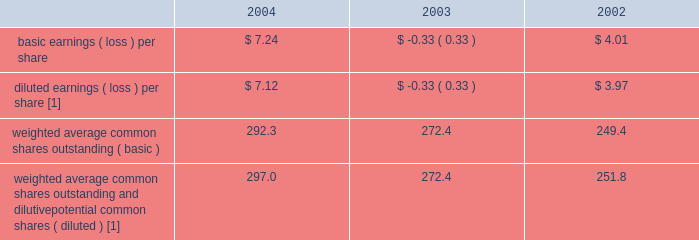Income was due primarily to the adoption of statement of position 03-1 , 201caccounting and reporting by insurance enterprises for certain nontraditional long-duration contracts and for separate accounts 201d ( 201csop 03-1 201d ) , which resulted in $ 1.6 billion of net investment income .
2003 compared to 2002 2014 revenues for the year ended december 31 , 2003 increased $ 2.3 billion over the comparable 2002 period .
Revenues increased due to earned premium growth within the business insurance , specialty commercial and personal lines segments , primarily as a result of earned pricing increases , higher earned premiums and net investment income in the retail products segment and net realized capital gains in 2003 as compared to net realized capital losses in 2002 .
Total benefits , claims and expenses increased $ 3.9 billion for the year ended december 31 , 2003 over the comparable prior year period primarily due to the company 2019s $ 2.6 billion asbestos reserve strengthening during the first quarter of 2003 and due to increases in the retail products segment associated with the growth in the individual annuity and institutional investments businesses .
The net loss for the year ended december 31 , 2003 was primarily due to the company 2019s first quarter 2003 asbestos reserve strengthening of $ 1.7 billion , after-tax .
Included in net loss for the year ended december 31 , 2003 are $ 40 of after-tax expense related to the settlement of litigation with bancorp services , llc ( 201cbancorp 201d ) and $ 27 of severance charges , after-tax , in property & casualty .
Included in net income for the year ended december 31 , 2002 are the $ 8 after-tax benefit recognized by hartford life , inc .
( 201chli 201d ) related to the reduction of hli 2019s reserves associated with september 11 and $ 11 of after-tax expense related to litigation with bancorp .
Net realized capital gains and losses see 201cinvestment results 201d in the investments section .
Income taxes the effective tax rate for 2004 , 2003 and 2002 was 15% ( 15 % ) , 83% ( 83 % ) and 6% ( 6 % ) , respectively .
The principal causes of the difference between the effective rates and the u.s .
Statutory rate of 35% ( 35 % ) were tax-exempt interest earned on invested assets , the dividends-received deduction , the tax benefit associated with the settlement of the 1998-2001 irs audit in 2004 and the tax benefit associated with the settlement of the 1996-1997 irs audit in 2002 .
Income taxes paid ( received ) in 2004 , 2003 and 2002 were $ 32 , ( $ 107 ) and ( $ 102 ) respectively .
For additional information , see note 13 of notes to consolidated financial statements .
Per common share the table represents earnings per common share data for the past three years: .
[1] as a result of the net loss for the year ended december 31 , 2003 , sfas no .
128 , 201cearnings per share 201d , requires the company to use basic weighted average common shares outstanding in the calculation of the year ended december 31 , 2003 diluted earnings ( loss ) per share , since the inclusion of options of 1.8 would have been antidilutive to the earnings per share calculation .
In the absence of the net loss , weighted average common shares outstanding and dilutive potential common shares would have totaled 274.2 .
Executive overview the company provides investment and retirement products such as variable and fixed annuities , mutual funds and retirement plan services and other institutional products ; individual and corporate owned life insurance ; and , group benefit products , such as group life and group disability insurance .
The company derives its revenues principally from : ( a ) fee income , including asset management fees , on separate account and mutual fund assets and mortality and expense fees , as well as cost of insurance charges ; ( b ) net investment income on general account assets ; ( c ) fully insured premiums ; and ( d ) certain other fees .
Asset management fees and mortality and expense fees are primarily generated from separate account assets , which are deposited with the company through the sale of variable annuity and variable universal life products and from mutual funds .
Cost of insurance charges are assessed on the net amount at risk for investment-oriented life insurance products .
Premium revenues are derived primarily from the sale of group life , and group disability and individual term insurance products .
The company 2019s expenses essentially consist of interest credited to policyholders on general account liabilities , insurance benefits provided , amortization of the deferred policy acquisition costs , expenses related to the selling and servicing the various products offered by the company , dividends to policyholders , and other general business expenses. .
What is the net income reported in 2004 , ( in millions ) ? 
Computations: (292.3 * 7.24)
Answer: 2116.252. 